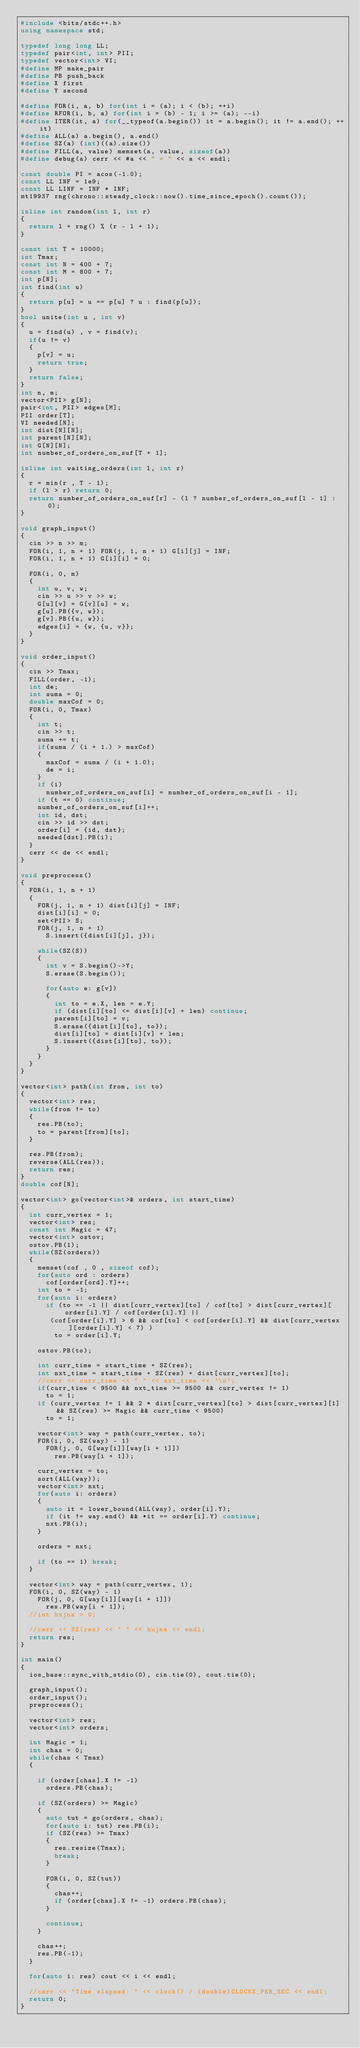<code> <loc_0><loc_0><loc_500><loc_500><_C++_>#include <bits/stdc++.h>
using namespace std;

typedef long long LL;
typedef pair<int, int> PII;
typedef vector<int> VI;
#define MP make_pair
#define PB push_back
#define X first
#define Y second

#define FOR(i, a, b) for(int i = (a); i < (b); ++i)
#define RFOR(i, b, a) for(int i = (b) - 1; i >= (a); --i)
#define ITER(it, a) for(__typeof(a.begin()) it = a.begin(); it != a.end(); ++it)
#define ALL(a) a.begin(), a.end()
#define SZ(a) (int)((a).size())
#define FILL(a, value) memset(a, value, sizeof(a))
#define debug(a) cerr << #a << " = " << a << endl;

const double PI = acos(-1.0);
const LL INF = 1e9;
const LL LINF = INF * INF;
mt19937 rng(chrono::steady_clock::now().time_since_epoch().count());

inline int random(int l, int r)
{
	return l + rng() % (r - l + 1);
}

const int T = 10000;
int Tmax;
const int N = 400 + 7;
const int M = 800 + 7;
int p[N];
int find(int u)
{
	return p[u] = u == p[u] ? u : find(p[u]);
}
bool unite(int u , int v)
{
	u = find(u) , v = find(v);
	if(u != v)
	{
		p[v] = u;
		return true;
	}
	return false;
}
int n, m;
vector<PII> g[N];
pair<int, PII> edges[M];
PII order[T];
VI needed[N];
int dist[N][N];
int parent[N][N];
int G[N][N];
int number_of_orders_on_suf[T + 1];

inline int waiting_orders(int l, int r)
{
	r = min(r , T - 1);
	if (l > r) return 0;
	return number_of_orders_on_suf[r] - (l ? number_of_orders_on_suf[l - 1] : 0);
}

void graph_input()
{
	cin >> n >> m;
	FOR(i, 1, n + 1) FOR(j, 1, n + 1) G[i][j] = INF;
	FOR(i, 1, n + 1) G[i][i] = 0;
	
	FOR(i, 0, m)
	{
		int u, v, w;
		cin >> u >> v >> w;
		G[u][v] = G[v][u] = w;
		g[u].PB({v, w});
		g[v].PB({u, w});
		edges[i] = {w, {u, v}};
	}
}

void order_input()
{
	cin >> Tmax;
	FILL(order, -1);
	int de;
	int suma = 0;
	double maxCof = 0;
	FOR(i, 0, Tmax)
	{
		int t;
		cin >> t;
		suma += t;
		if(suma / (i + 1.) > maxCof)
		{
			maxCof = suma / (i + 1.0);
			de = i;
		}
		if (i)
			number_of_orders_on_suf[i] = number_of_orders_on_suf[i - 1];
		if (t == 0) continue;
		number_of_orders_on_suf[i]++;
		int id, dst;
		cin >> id >> dst;
		order[i] = {id, dst};
		needed[dst].PB(i);		
	}
	cerr << de << endl;
}

void preprocess()
{
	FOR(i, 1, n + 1)
	{
		FOR(j, 1, n + 1) dist[i][j] = INF;
		dist[i][i] = 0;
		set<PII> S;
		FOR(j, 1, n + 1)
			S.insert({dist[i][j], j});
		
		while(SZ(S))
		{
			int v = S.begin()->Y;
			S.erase(S.begin());
			
			for(auto e: g[v])
			{
				int to = e.X, len = e.Y;
				if (dist[i][to] <= dist[i][v] + len) continue;
				parent[i][to] = v;
				S.erase({dist[i][to], to});
				dist[i][to] = dist[i][v] + len;
				S.insert({dist[i][to], to});
			}
		}
	}
}

vector<int> path(int from, int to)
{
	vector<int> res;
	while(from != to)
	{
		res.PB(to);
		to = parent[from][to];
	}
	
	res.PB(from);
	reverse(ALL(res));
	return res;
}
double cof[N];

vector<int> go(vector<int>& orders, int start_time)
{
	int curr_vertex = 1;
	vector<int> res;
	const int Magic = 47;
	vector<int> ostov;
	ostov.PB(1);
	while(SZ(orders))
	{
		memset(cof , 0 , sizeof cof);
		for(auto ord : orders)
			cof[order[ord].Y]++;
		int to = -1;
		for(auto i: orders)
			if (to == -1 || dist[curr_vertex][to] / cof[to] > dist[curr_vertex][order[i].Y] / cof[order[i].Y] ||
			 (cof[order[i].Y] > 6 && cof[to] < cof[order[i].Y] && dist[curr_vertex][order[i].Y] < 7) )
				to = order[i].Y;
		
		ostov.PB(to);
		
		int curr_time = start_time + SZ(res);
		int nxt_time = start_time + SZ(res) + dist[curr_vertex][to];
		//cerr << curr_time << " " << nxt_time << '\n';
		if(curr_time < 9500 && nxt_time >= 9500 && curr_vertex != 1)
			to = 1;
		if (curr_vertex != 1 && 2 * dist[curr_vertex][to] > dist[curr_vertex][1] && SZ(res) >= Magic && curr_time < 9500)
			to = 1;
		
		vector<int> way = path(curr_vertex, to);
		FOR(i, 0, SZ(way) - 1)
			FOR(j, 0, G[way[i]][way[i + 1]])
				res.PB(way[i + 1]);
		
		curr_vertex = to;
		sort(ALL(way));
		vector<int> nxt;
		for(auto i: orders)
		{
			auto it = lower_bound(ALL(way), order[i].Y);
			if (it != way.end() && *it == order[i].Y) continue;
			nxt.PB(i);
		}
		
		orders = nxt;
		
		if (to == 1) break;
	}	
	
	vector<int> way = path(curr_vertex, 1);
	FOR(i, 0, SZ(way) - 1)
		FOR(j, 0, G[way[i]][way[i + 1]])
			res.PB(way[i + 1]);
	//int hujna = 0;
	
	//cerr << SZ(res) << " " << hujna << endl;
	return res;
}

int main()
{
	ios_base::sync_with_stdio(0), cin.tie(0), cout.tie(0);
	
	graph_input();
	order_input();
	preprocess();
	
	vector<int> res;
	vector<int> orders;
	
	int Magic = 1;
	int chas = 0;
	while(chas < Tmax)
	{
		
		if (order[chas].X != -1)
			orders.PB(chas);
			
		if (SZ(orders) >= Magic)
		{
			auto tut = go(orders, chas);
			for(auto i: tut) res.PB(i);
			if (SZ(res) >= Tmax)
			{
				res.resize(Tmax);
				break;
			}
			
			FOR(i, 0, SZ(tut))
			{
				chas++;
				if (order[chas].X != -1) orders.PB(chas);
			}
			
			continue;
		}
		
		chas++;	
		res.PB(-1);
	}
	
	for(auto i: res) cout << i << endl;
	
	//cerr << "Time elapsed: " << clock() / (double)CLOCKS_PER_SEC << endl;
	return 0;
}
</code> 